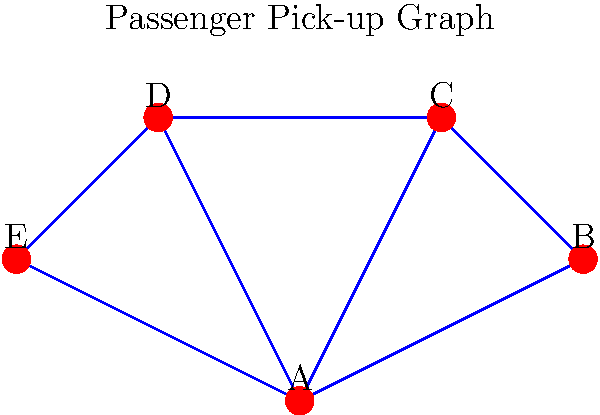As a savvy Lyft driver looking to optimize your routes and outperform Uber, you're presented with a weighted graph representing potential passenger pick-up locations. The vertices A, B, C, D, and E represent different locations, and the edge weights represent the time (in minutes) to travel between them. Starting from location A, what is the most efficient order to pick up all passengers if you must return to A, and what is the total time for this route? To solve this problem, we need to find the Hamiltonian cycle with the minimum total weight, also known as the Traveling Salesman Problem (TSP). Here's a step-by-step approach:

1) List all possible Hamiltonian cycles starting and ending at A:
   A-B-C-D-E-A
   A-B-C-E-D-A
   A-B-D-C-E-A
   A-B-D-E-C-A
   A-B-E-C-D-A
   A-B-E-D-C-A
   (and their reverse orders)

2) Calculate the total weight for each cycle:
   A-B-C-D-E-A: 5 + 3 + 2 + 3 + 7 = 20
   A-B-C-E-D-A: 5 + 3 + (2+3) + 6 = 19
   A-B-D-C-E-A: 5 + (3+2) + 3 + 7 = 20
   A-B-D-E-C-A: 5 + 6 + 3 + (2+3) = 19
   A-B-E-C-D-A: 5 + (3+2) + 3 + 6 = 19
   A-B-E-D-C-A: 5 + 7 + 3 + 2 + 4 = 21

3) Identify the minimum weight cycle(s):
   There are three cycles with the minimum weight of 19:
   A-B-C-E-D-A
   A-B-D-E-C-A
   A-B-E-C-D-A

4) Choose one of these optimal routes. Let's select A-B-C-E-D-A.

Therefore, the most efficient order to pick up all passengers is A-B-C-E-D-A, and the total time for this route is 19 minutes.
Answer: A-B-C-E-D-A, 19 minutes 